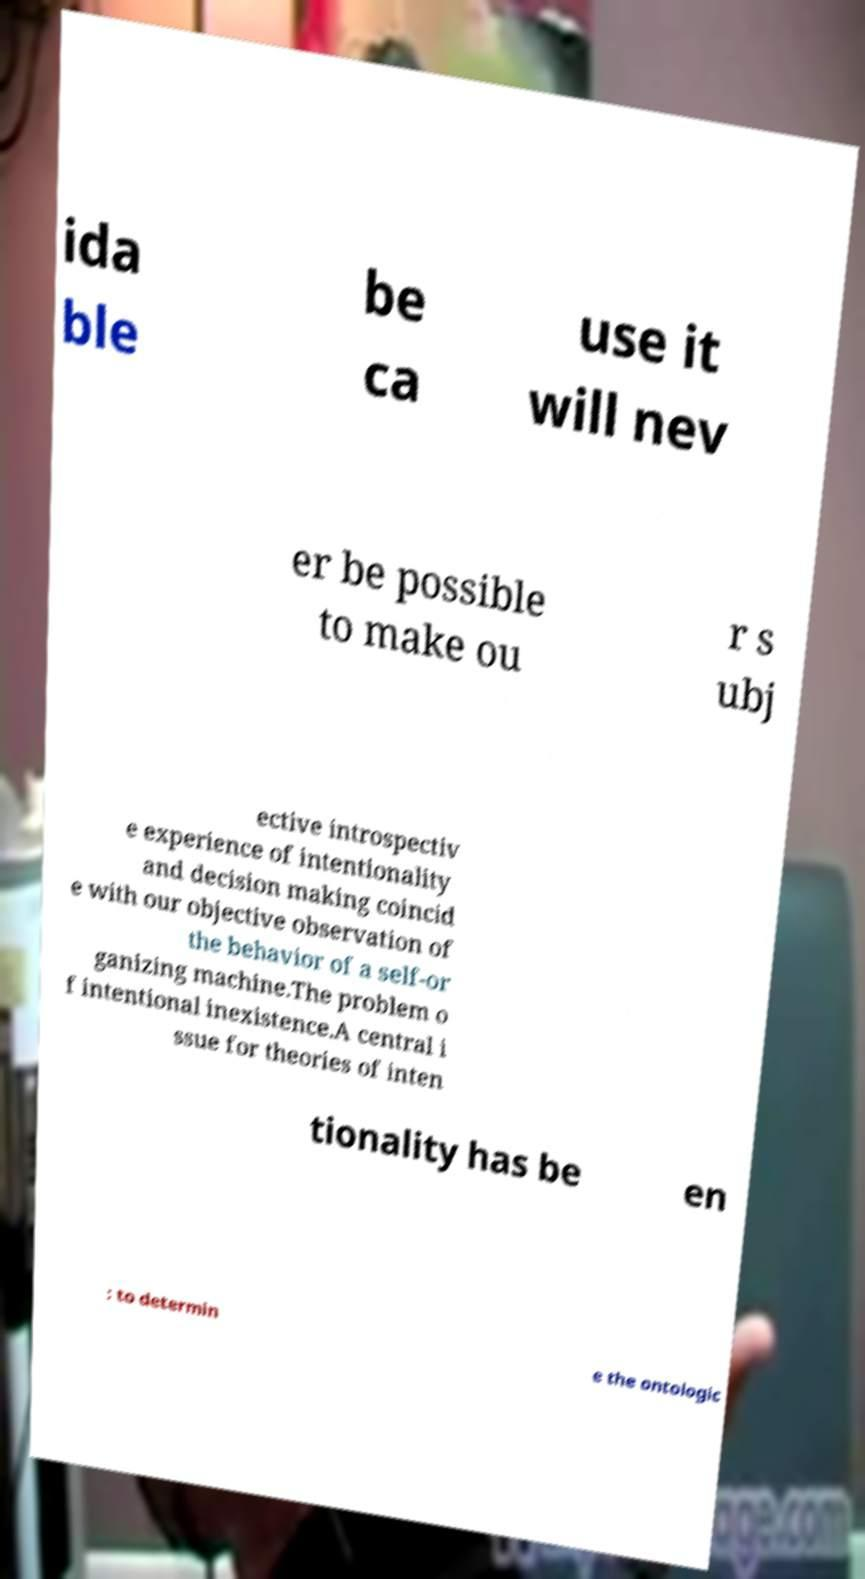Please identify and transcribe the text found in this image. ida ble be ca use it will nev er be possible to make ou r s ubj ective introspectiv e experience of intentionality and decision making coincid e with our objective observation of the behavior of a self-or ganizing machine.The problem o f intentional inexistence.A central i ssue for theories of inten tionality has be en : to determin e the ontologic 